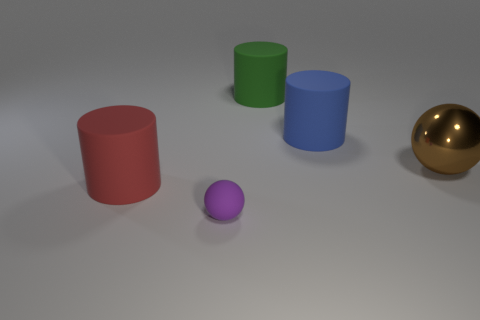Subtract all blue cylinders. How many cylinders are left? 2 Add 3 large objects. How many objects exist? 8 Subtract all green cylinders. How many cylinders are left? 2 Subtract 1 spheres. How many spheres are left? 1 Add 2 tiny gray metal cubes. How many tiny gray metal cubes exist? 2 Subtract 1 purple balls. How many objects are left? 4 Subtract all cylinders. How many objects are left? 2 Subtract all blue spheres. Subtract all blue cylinders. How many spheres are left? 2 Subtract all purple matte things. Subtract all green matte objects. How many objects are left? 3 Add 3 tiny spheres. How many tiny spheres are left? 4 